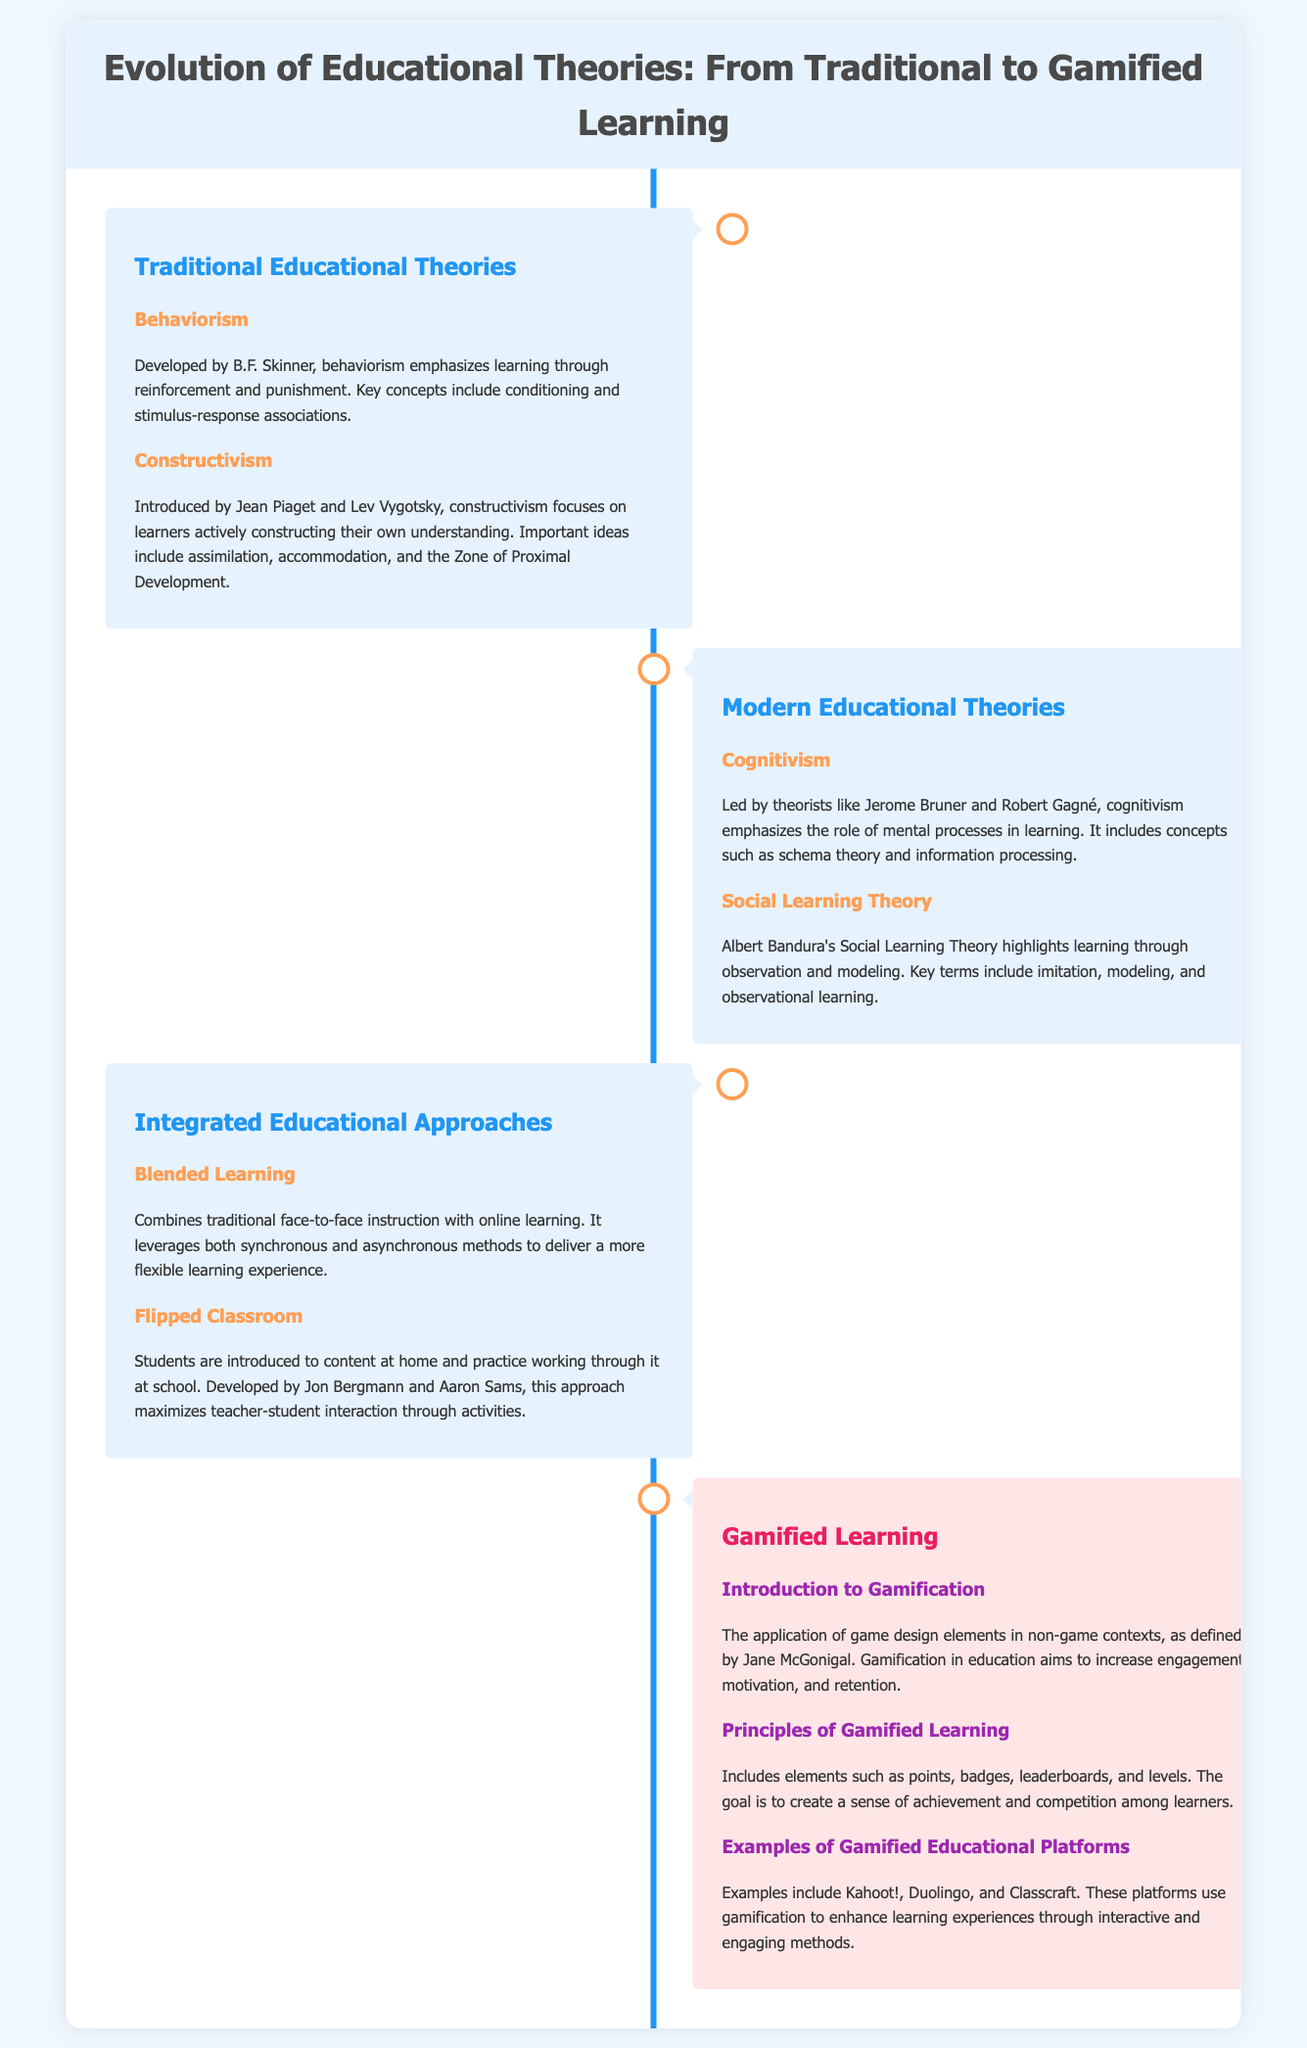What are the two types of Traditional Educational Theories? The document lists Behaviorism and Constructivism as the two types of Traditional Educational Theories.
Answer: Behaviorism and Constructivism Who introduced Constructivism? Constructivism was introduced by Jean Piaget and Lev Vygotsky, as stated in the document.
Answer: Jean Piaget and Lev Vygotsky What theory emphasizes the role of mental processes in learning? The document mentions Cognitivism as the theory that emphasizes mental processes in learning.
Answer: Cognitivism What is one of the principles of Gamified Learning? The document lists points, badges, leaderboards, and levels as principles of Gamified Learning.
Answer: Points What approach combines traditional instruction with online learning? The document refers to Blended Learning as the approach that combines these two methods.
Answer: Blended Learning Who are the developers of the Flipped Classroom approach? The document cites Jon Bergmann and Aaron Sams as the developers of the Flipped Classroom approach.
Answer: Jon Bergmann and Aaron Sams What is one example of a gamified educational platform? The document provides Kahoot!, Duolingo, and Classcraft as examples of gamified educational platforms.
Answer: Kahoot! What is the main goal of Gamification in education? According to the document, the main goal of Gamification is to increase engagement, motivation, and retention.
Answer: Increase engagement, motivation, and retention What are the three categories of educational theories mentioned in the infographic? The document delineates Traditional Educational Theories, Modern Educational Theories, and Integrated Educational Approaches as the three categories.
Answer: Traditional, Modern, and Integrated Educational Theories 